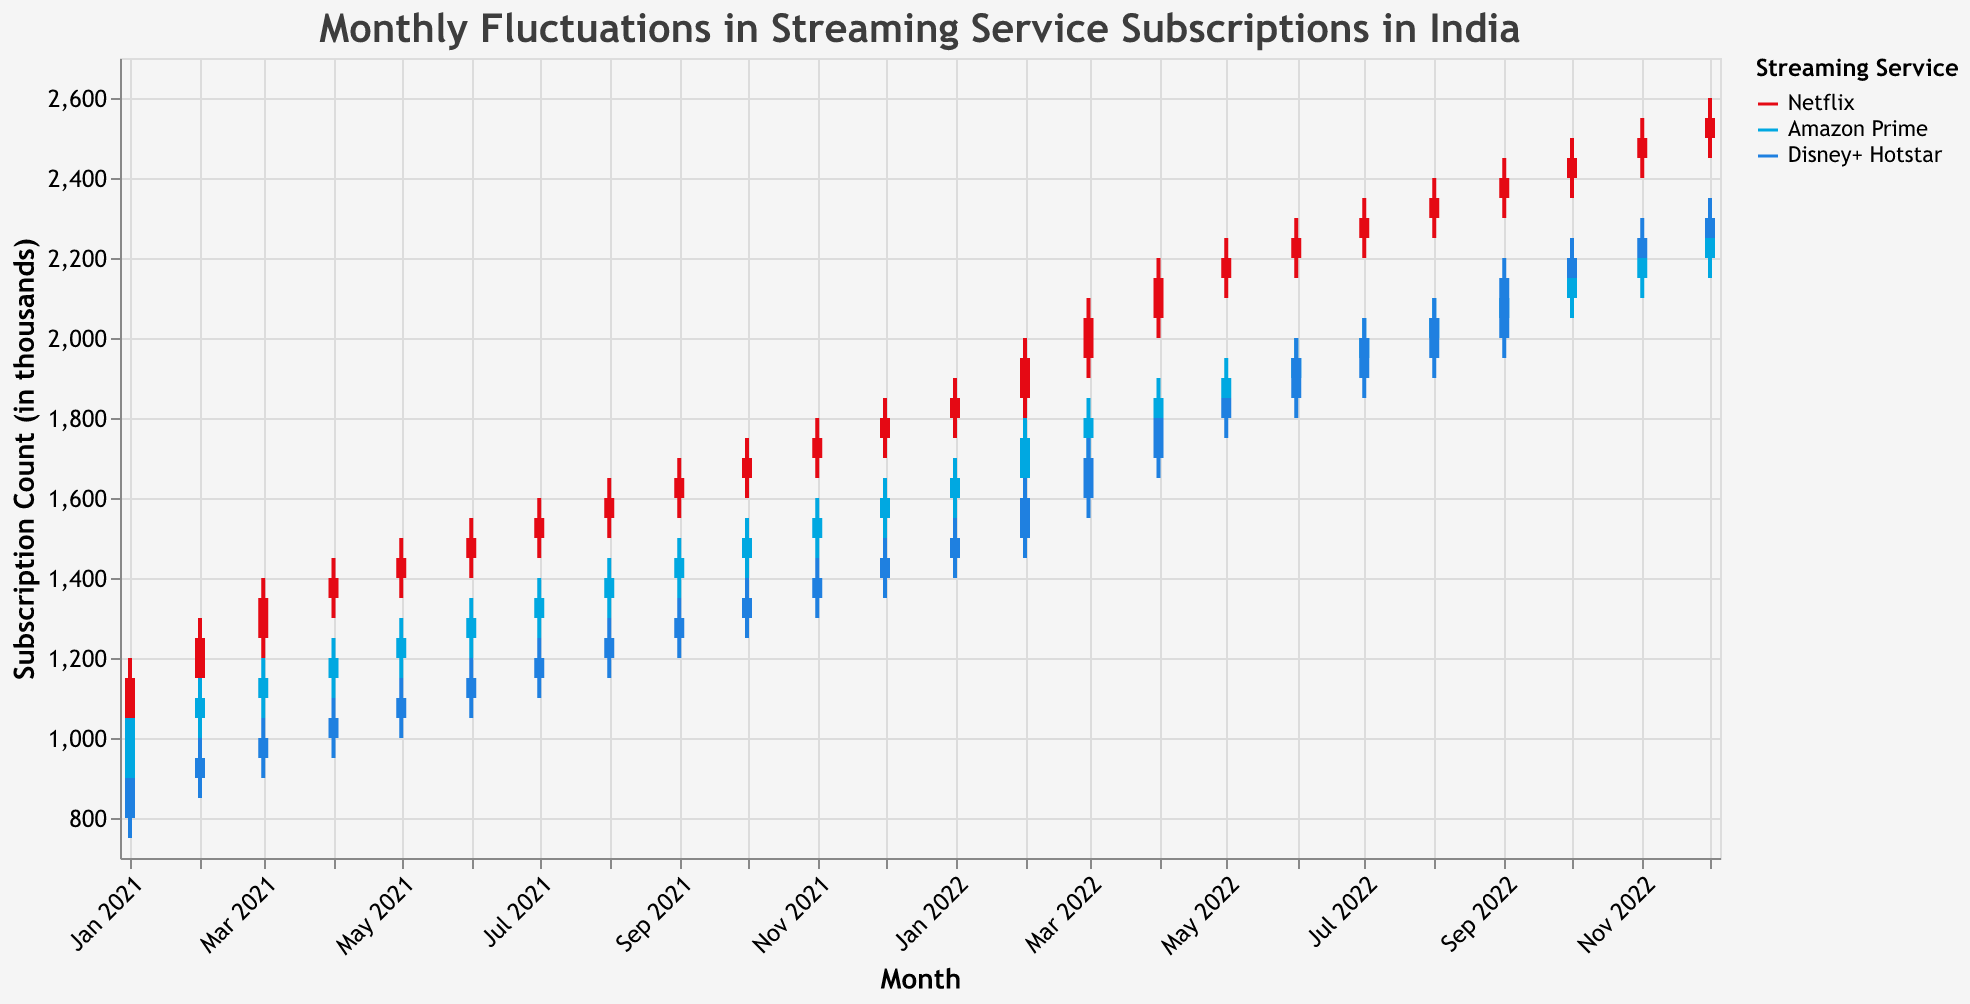What is the title of the figure? The title of the figure is displayed at the top in a larger and bold font. It states the overall content and context of the figure.
Answer: "Monthly Fluctuations in Streaming Service Subscriptions in India" Which streaming service had the highest number of subscriptions in December 2022? Look at the candlestick for December 2022 and identify the service with the highest "High" value. Netflix showed the highest peak among all services.
Answer: Netflix What is the color used to represent Disney+ Hotstar? The color used for Disney+ Hotstar is shown in the legend on the right side of the figure.
Answer: Blue During which month did Netflix subscriptions reach 1600? Find the candlestick where Netflix subscriptions reach 1600 by checking the "Close" value. The candlestick in August 2021 shows a close of 1600 for Netflix.
Answer: August 2021 Compare the opening subscription counts for Amazon Prime and Disney+ Hotstar in February 2021. Which one was higher? Check the "Open" values for both Amazon Prime and Disney+ Hotstar in February 2021. Amazon Prime had an opening of 1050, while Disney+ Hotstar had 900.
Answer: Amazon Prime What was the highest subscription count for Netflix in the period shown? Identify the highest "High" value in all the candlesticks representing Netflix. This value reached 2600 in December 2022.
Answer: 2600 Calculate the average closing subscription count for Netflix from January 2021 to December 2021. Sum the closing values for each month and divide by the number of months. Sum for 2021: (1150 + 1250 + 1350 + 1400 + 1450 + 1500+ 1550 + 1600 + 1650 + 1700 + 1750 + 1800) = 18350. Average = 18350 / 12 = 1529.17
Answer: 1529.17 Which streaming service had the smallest range of subscriptions (High-Low) in July 2022? Examine the candlestick for July 2022 for each service and calculate the range (High-Low). Netflix had a range of 150, Amazon Prime had a range of 150, and Disney+ Hotstar had a range of 200. Netflix and Amazon Prime have the smallest range.
Answer: Netflix, Amazon Prime In which month did Amazon Prime subscriptions exceed 2000 for the first time? Look at Amazon Prime's candlesticks and find where the "Close" value first exceeds 2000. This occurred in September 2022.
Answer: September 2022 